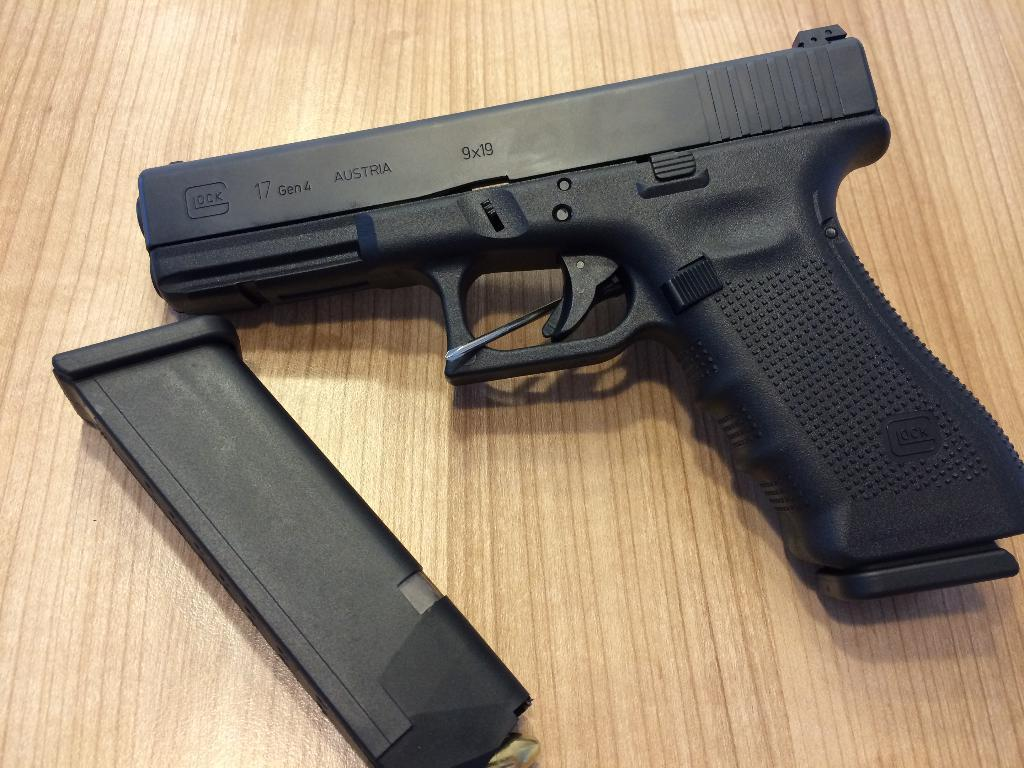What type of object is present in the image? There is a black color gun in the image. What other item is related to the gun in the image? There is a black color magazine in the image. On what surface are the gun and magazine placed? Both the gun and magazine are on a wooden board. What type of noise can be heard coming from the church in the image? There is no church present in the image, so it's not possible to determine what, if any, noise might be heard. 